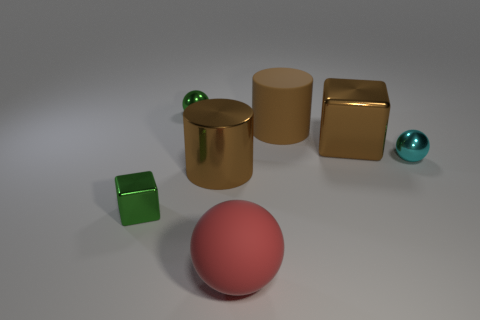Add 1 cyan metallic spheres. How many objects exist? 8 Subtract all balls. How many objects are left? 4 Subtract all tiny cyan metallic balls. Subtract all small green cubes. How many objects are left? 5 Add 7 tiny green cubes. How many tiny green cubes are left? 8 Add 2 rubber objects. How many rubber objects exist? 4 Subtract 1 green spheres. How many objects are left? 6 